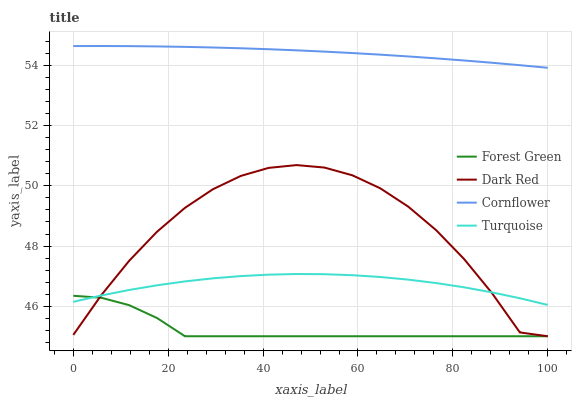Does Turquoise have the minimum area under the curve?
Answer yes or no. No. Does Turquoise have the maximum area under the curve?
Answer yes or no. No. Is Forest Green the smoothest?
Answer yes or no. No. Is Forest Green the roughest?
Answer yes or no. No. Does Turquoise have the lowest value?
Answer yes or no. No. Does Turquoise have the highest value?
Answer yes or no. No. Is Forest Green less than Cornflower?
Answer yes or no. Yes. Is Cornflower greater than Turquoise?
Answer yes or no. Yes. Does Forest Green intersect Cornflower?
Answer yes or no. No. 